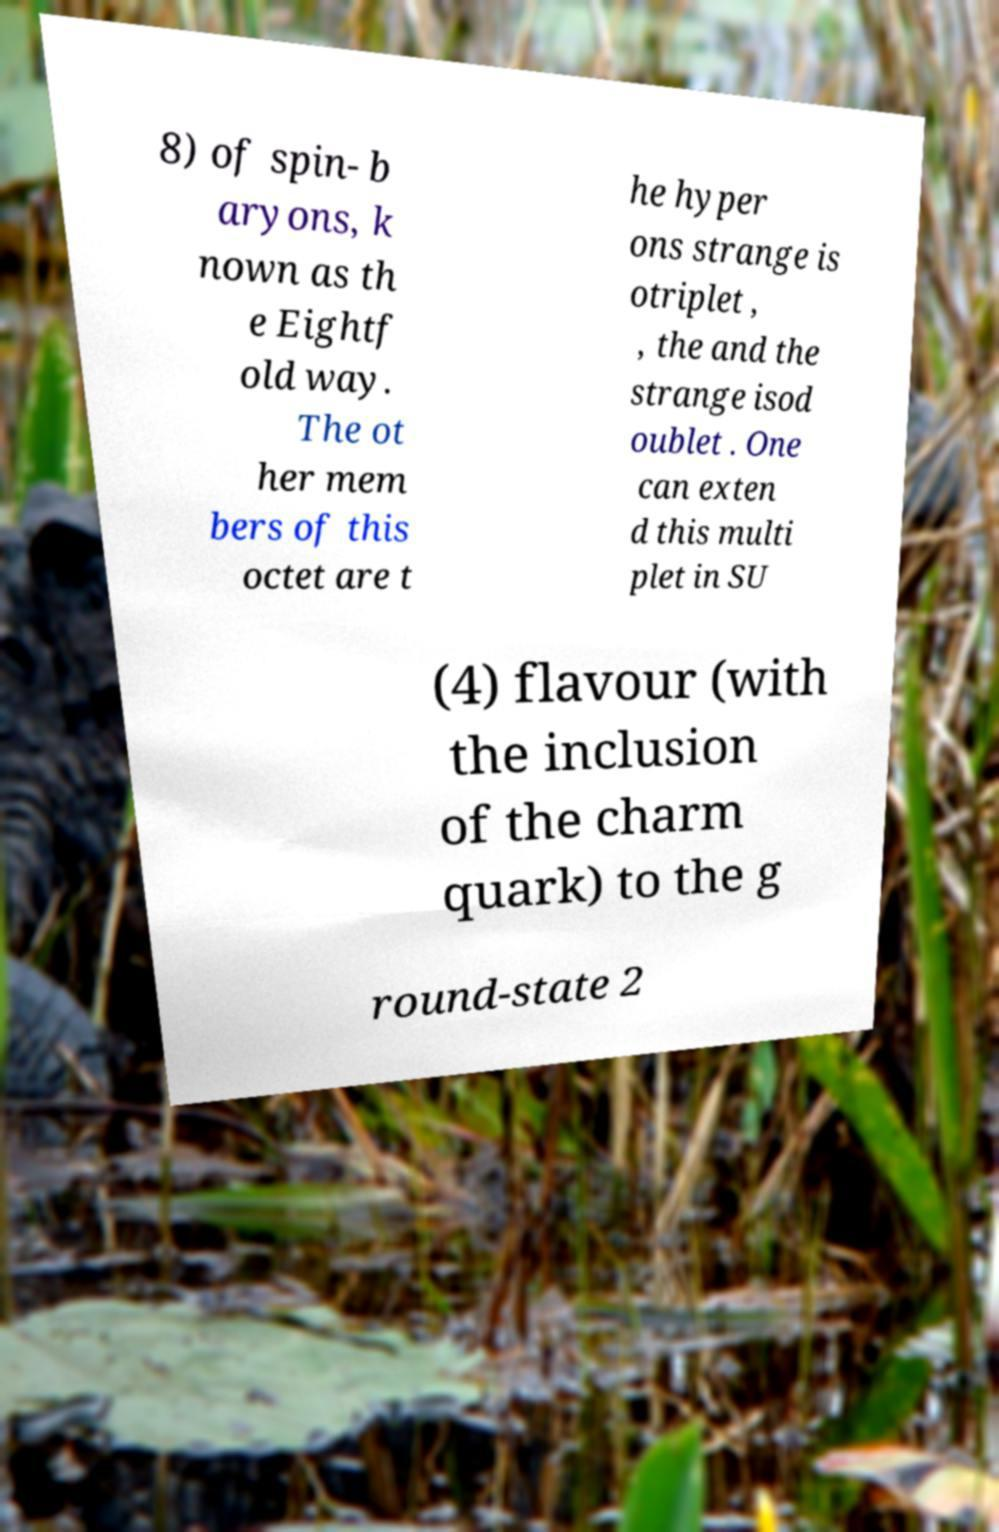I need the written content from this picture converted into text. Can you do that? 8) of spin- b aryons, k nown as th e Eightf old way. The ot her mem bers of this octet are t he hyper ons strange is otriplet , , the and the strange isod oublet . One can exten d this multi plet in SU (4) flavour (with the inclusion of the charm quark) to the g round-state 2 